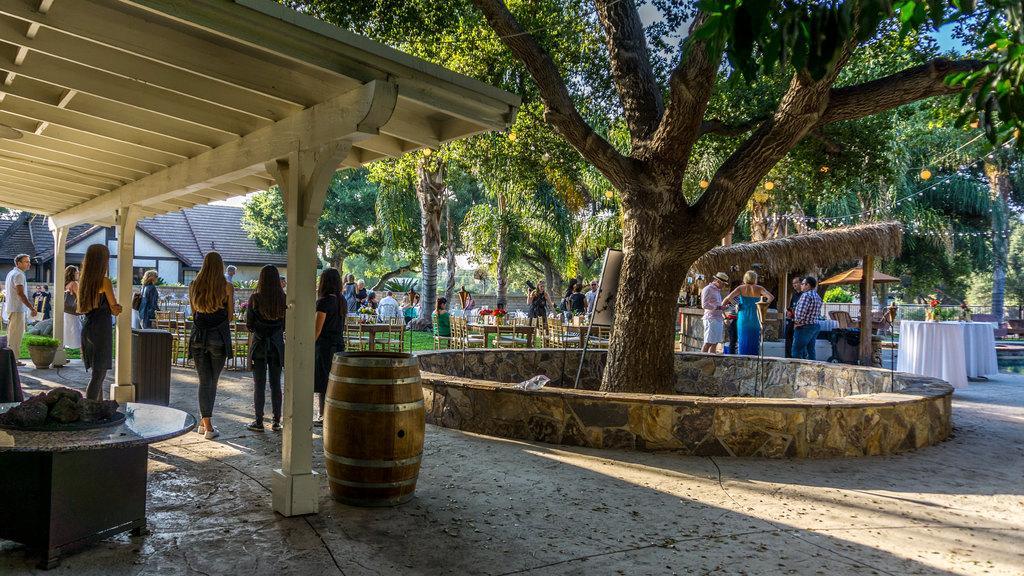How would you summarize this image in a sentence or two? In this picture, In the right side there is a tree which is in green color, In the left side there is a table which is in black color and there is a shed in white color, There are some people standing in the shed. 